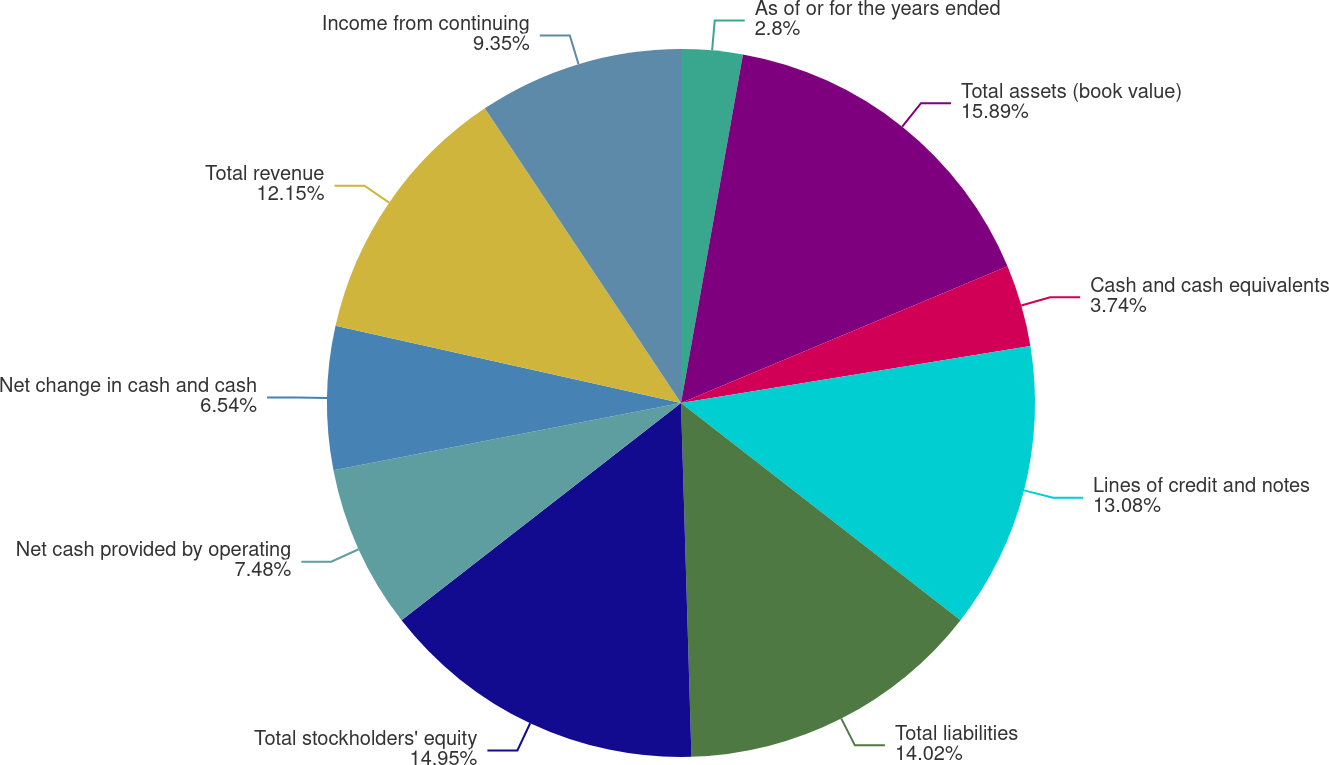Convert chart to OTSL. <chart><loc_0><loc_0><loc_500><loc_500><pie_chart><fcel>As of or for the years ended<fcel>Total assets (book value)<fcel>Cash and cash equivalents<fcel>Lines of credit and notes<fcel>Total liabilities<fcel>Total stockholders' equity<fcel>Net cash provided by operating<fcel>Net change in cash and cash<fcel>Total revenue<fcel>Income from continuing<nl><fcel>2.8%<fcel>15.89%<fcel>3.74%<fcel>13.08%<fcel>14.02%<fcel>14.95%<fcel>7.48%<fcel>6.54%<fcel>12.15%<fcel>9.35%<nl></chart> 